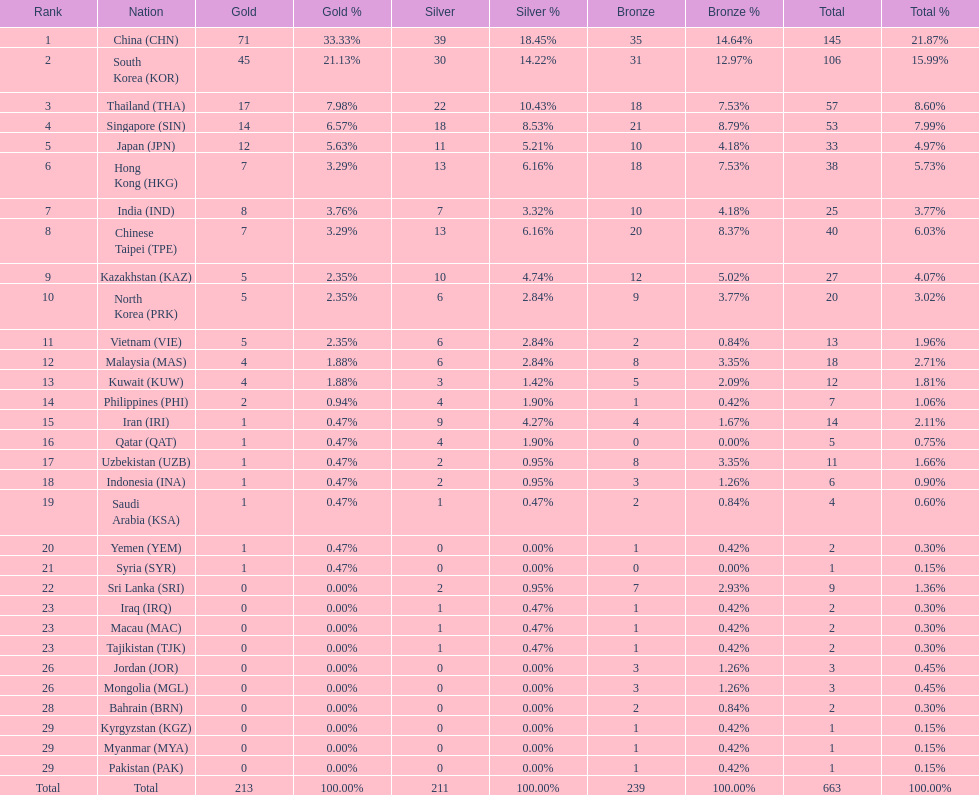What is the complete tally of medals that india achieved in the asian youth games? 25. 